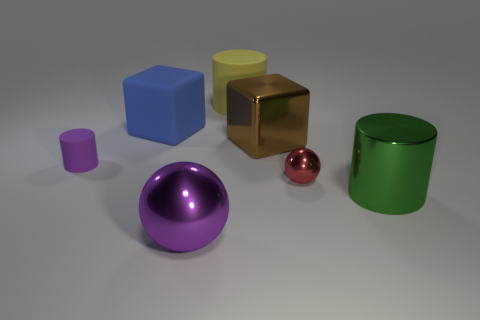Subtract all large cylinders. How many cylinders are left? 1 Add 2 large spheres. How many objects exist? 9 Subtract all blue cubes. How many cubes are left? 1 Subtract all cubes. How many objects are left? 5 Add 2 large brown metal things. How many large brown metal things exist? 3 Subtract 1 blue blocks. How many objects are left? 6 Subtract 3 cylinders. How many cylinders are left? 0 Subtract all yellow cylinders. Subtract all yellow cubes. How many cylinders are left? 2 Subtract all small things. Subtract all tiny purple matte cylinders. How many objects are left? 4 Add 7 yellow rubber cylinders. How many yellow rubber cylinders are left? 8 